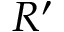Convert formula to latex. <formula><loc_0><loc_0><loc_500><loc_500>R ^ { \prime }</formula> 